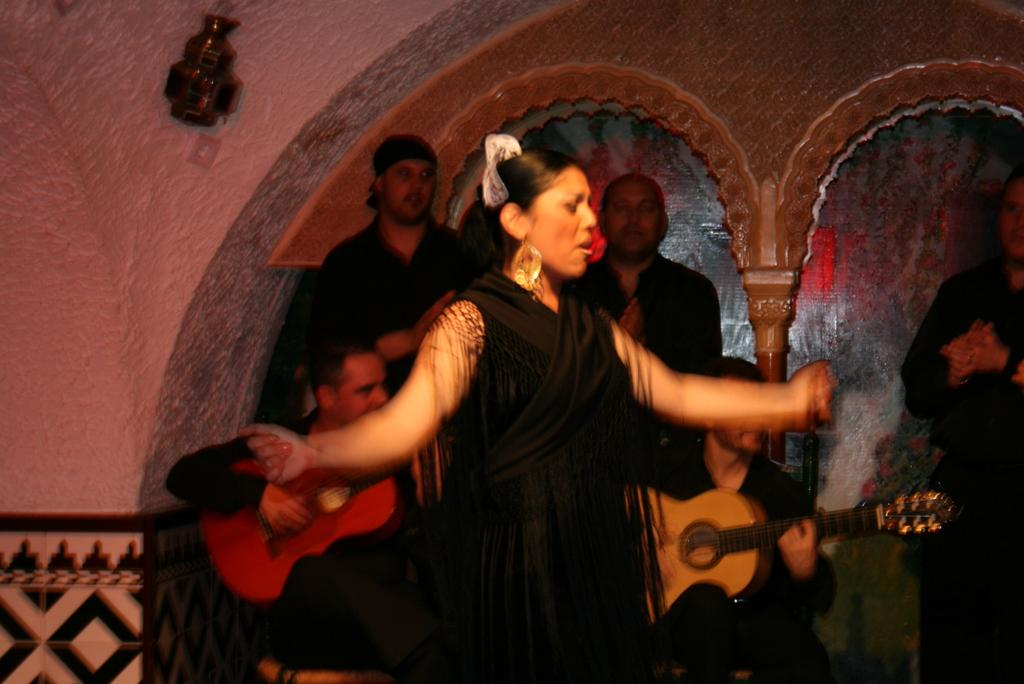Who is the main subject in the image? There is a woman in the image. What is the woman doing in the image? The woman is singing. Are there any other people in the image? Yes, there are people standing behind the woman. What is one of the people doing? One of the people is playing a guitar. Can you see any boats in the image? There are no boats present in the image. Is there a scarecrow standing next to the woman in the image? There is no scarecrow present in the image. 